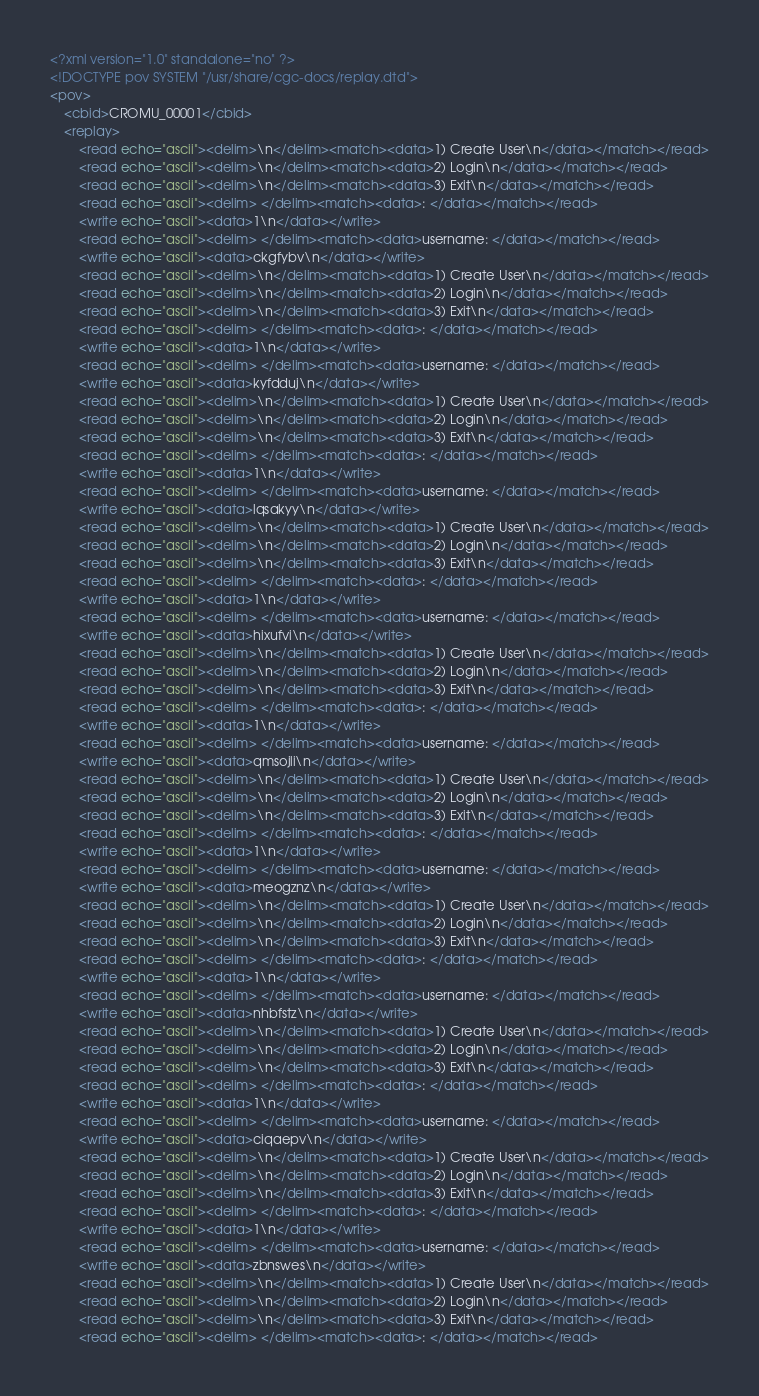Convert code to text. <code><loc_0><loc_0><loc_500><loc_500><_XML_><?xml version="1.0" standalone="no" ?>
<!DOCTYPE pov SYSTEM "/usr/share/cgc-docs/replay.dtd">
<pov>
	<cbid>CROMU_00001</cbid>
	<replay>
		<read echo="ascii"><delim>\n</delim><match><data>1) Create User\n</data></match></read>
		<read echo="ascii"><delim>\n</delim><match><data>2) Login\n</data></match></read>
		<read echo="ascii"><delim>\n</delim><match><data>3) Exit\n</data></match></read>
		<read echo="ascii"><delim> </delim><match><data>: </data></match></read>
		<write echo="ascii"><data>1\n</data></write>
		<read echo="ascii"><delim> </delim><match><data>username: </data></match></read>
		<write echo="ascii"><data>ckgfybv\n</data></write>
		<read echo="ascii"><delim>\n</delim><match><data>1) Create User\n</data></match></read>
		<read echo="ascii"><delim>\n</delim><match><data>2) Login\n</data></match></read>
		<read echo="ascii"><delim>\n</delim><match><data>3) Exit\n</data></match></read>
		<read echo="ascii"><delim> </delim><match><data>: </data></match></read>
		<write echo="ascii"><data>1\n</data></write>
		<read echo="ascii"><delim> </delim><match><data>username: </data></match></read>
		<write echo="ascii"><data>kyfdduj\n</data></write>
		<read echo="ascii"><delim>\n</delim><match><data>1) Create User\n</data></match></read>
		<read echo="ascii"><delim>\n</delim><match><data>2) Login\n</data></match></read>
		<read echo="ascii"><delim>\n</delim><match><data>3) Exit\n</data></match></read>
		<read echo="ascii"><delim> </delim><match><data>: </data></match></read>
		<write echo="ascii"><data>1\n</data></write>
		<read echo="ascii"><delim> </delim><match><data>username: </data></match></read>
		<write echo="ascii"><data>lqsakyy\n</data></write>
		<read echo="ascii"><delim>\n</delim><match><data>1) Create User\n</data></match></read>
		<read echo="ascii"><delim>\n</delim><match><data>2) Login\n</data></match></read>
		<read echo="ascii"><delim>\n</delim><match><data>3) Exit\n</data></match></read>
		<read echo="ascii"><delim> </delim><match><data>: </data></match></read>
		<write echo="ascii"><data>1\n</data></write>
		<read echo="ascii"><delim> </delim><match><data>username: </data></match></read>
		<write echo="ascii"><data>hixufvi\n</data></write>
		<read echo="ascii"><delim>\n</delim><match><data>1) Create User\n</data></match></read>
		<read echo="ascii"><delim>\n</delim><match><data>2) Login\n</data></match></read>
		<read echo="ascii"><delim>\n</delim><match><data>3) Exit\n</data></match></read>
		<read echo="ascii"><delim> </delim><match><data>: </data></match></read>
		<write echo="ascii"><data>1\n</data></write>
		<read echo="ascii"><delim> </delim><match><data>username: </data></match></read>
		<write echo="ascii"><data>qmsojli\n</data></write>
		<read echo="ascii"><delim>\n</delim><match><data>1) Create User\n</data></match></read>
		<read echo="ascii"><delim>\n</delim><match><data>2) Login\n</data></match></read>
		<read echo="ascii"><delim>\n</delim><match><data>3) Exit\n</data></match></read>
		<read echo="ascii"><delim> </delim><match><data>: </data></match></read>
		<write echo="ascii"><data>1\n</data></write>
		<read echo="ascii"><delim> </delim><match><data>username: </data></match></read>
		<write echo="ascii"><data>meogznz\n</data></write>
		<read echo="ascii"><delim>\n</delim><match><data>1) Create User\n</data></match></read>
		<read echo="ascii"><delim>\n</delim><match><data>2) Login\n</data></match></read>
		<read echo="ascii"><delim>\n</delim><match><data>3) Exit\n</data></match></read>
		<read echo="ascii"><delim> </delim><match><data>: </data></match></read>
		<write echo="ascii"><data>1\n</data></write>
		<read echo="ascii"><delim> </delim><match><data>username: </data></match></read>
		<write echo="ascii"><data>nhbfstz\n</data></write>
		<read echo="ascii"><delim>\n</delim><match><data>1) Create User\n</data></match></read>
		<read echo="ascii"><delim>\n</delim><match><data>2) Login\n</data></match></read>
		<read echo="ascii"><delim>\n</delim><match><data>3) Exit\n</data></match></read>
		<read echo="ascii"><delim> </delim><match><data>: </data></match></read>
		<write echo="ascii"><data>1\n</data></write>
		<read echo="ascii"><delim> </delim><match><data>username: </data></match></read>
		<write echo="ascii"><data>ciqaepv\n</data></write>
		<read echo="ascii"><delim>\n</delim><match><data>1) Create User\n</data></match></read>
		<read echo="ascii"><delim>\n</delim><match><data>2) Login\n</data></match></read>
		<read echo="ascii"><delim>\n</delim><match><data>3) Exit\n</data></match></read>
		<read echo="ascii"><delim> </delim><match><data>: </data></match></read>
		<write echo="ascii"><data>1\n</data></write>
		<read echo="ascii"><delim> </delim><match><data>username: </data></match></read>
		<write echo="ascii"><data>zbnswes\n</data></write>
		<read echo="ascii"><delim>\n</delim><match><data>1) Create User\n</data></match></read>
		<read echo="ascii"><delim>\n</delim><match><data>2) Login\n</data></match></read>
		<read echo="ascii"><delim>\n</delim><match><data>3) Exit\n</data></match></read>
		<read echo="ascii"><delim> </delim><match><data>: </data></match></read></code> 